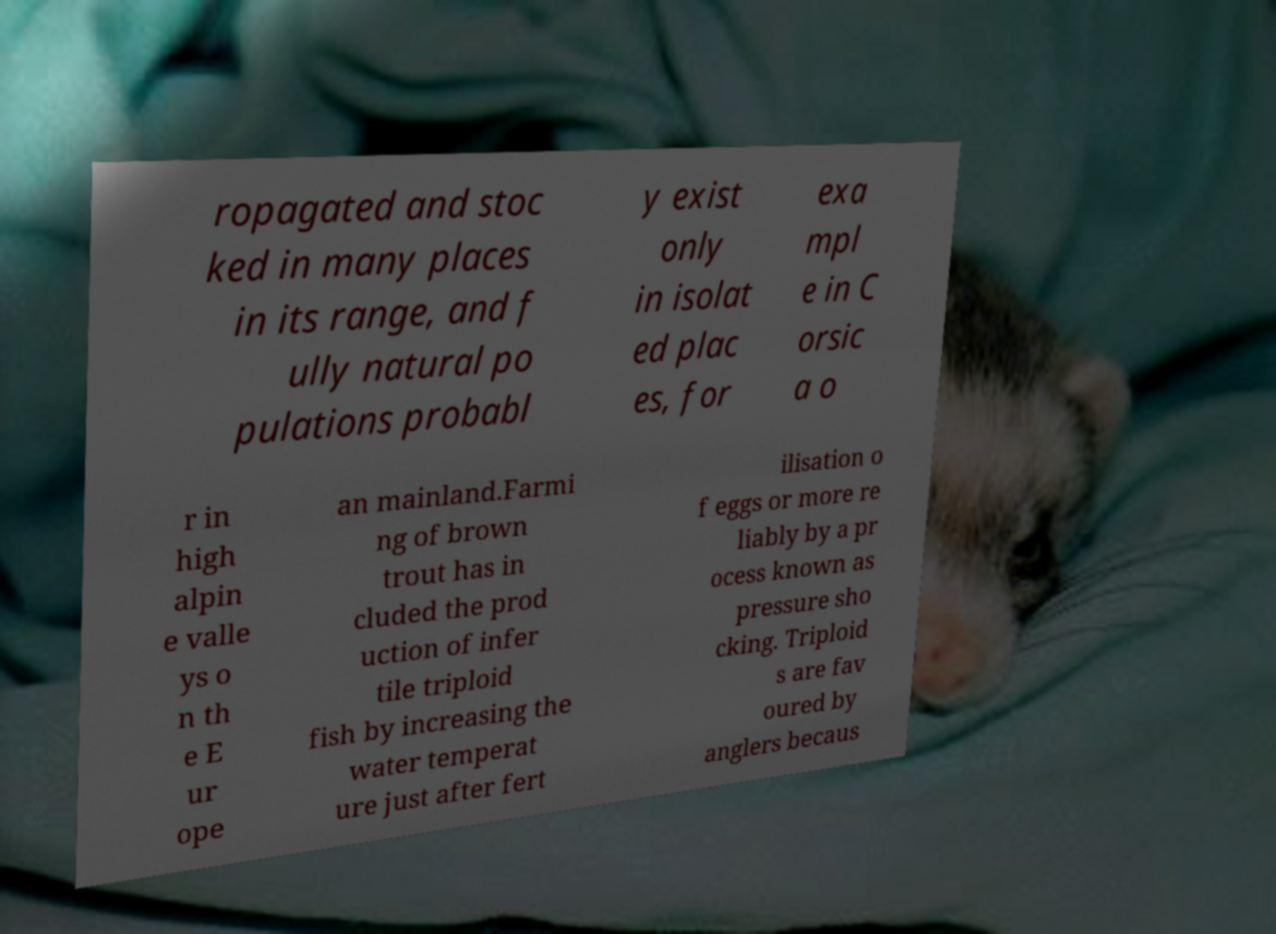I need the written content from this picture converted into text. Can you do that? ropagated and stoc ked in many places in its range, and f ully natural po pulations probabl y exist only in isolat ed plac es, for exa mpl e in C orsic a o r in high alpin e valle ys o n th e E ur ope an mainland.Farmi ng of brown trout has in cluded the prod uction of infer tile triploid fish by increasing the water temperat ure just after fert ilisation o f eggs or more re liably by a pr ocess known as pressure sho cking. Triploid s are fav oured by anglers becaus 